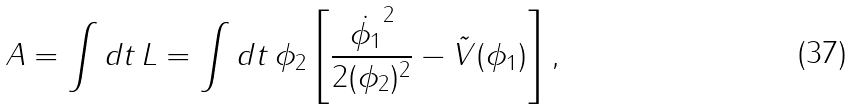<formula> <loc_0><loc_0><loc_500><loc_500>A = \int d t \, L = \int d t \, \phi _ { 2 } \left [ \frac { \dot { \phi _ { 1 } } ^ { 2 } } { 2 ( \phi _ { 2 } ) ^ { 2 } } - \tilde { V } ( \phi _ { 1 } ) \right ] ,</formula> 